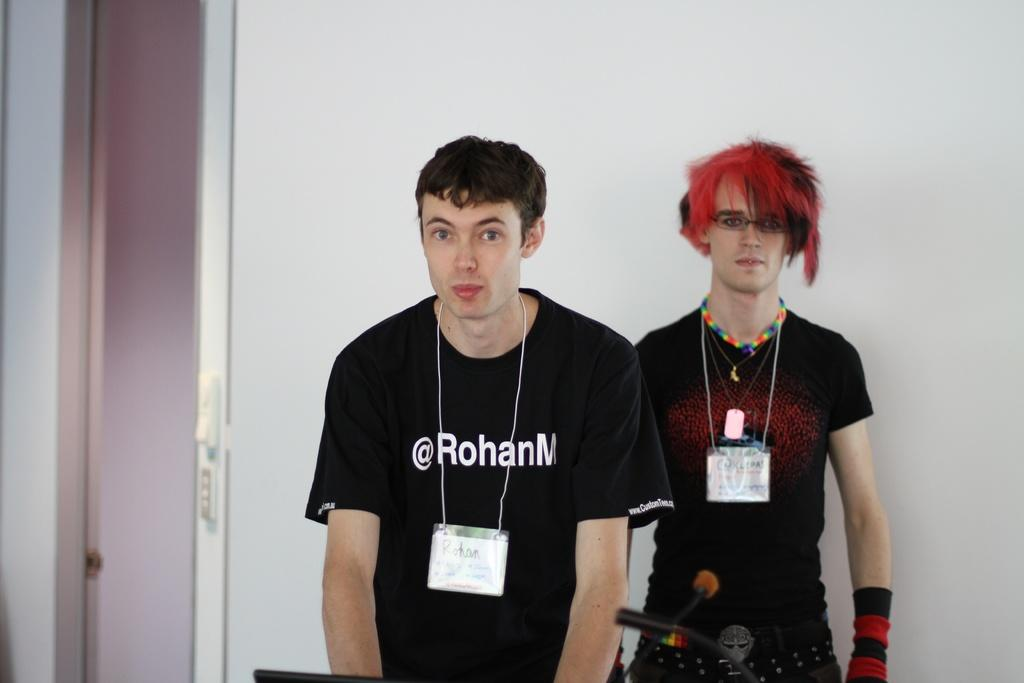How many people are in the image? There are two men in the image. What are the men doing in the image? The men are standing. What can be seen on the men's clothing? The men are wearing ID cards. What color is the wall in the background of the image? The wall in the background of the image is white. What else can be seen in the background of the image? There are other objects visible in the background of the image. How does the guide help the men in the image? There is no guide present in the image; it only features two men standing and wearing ID cards. 